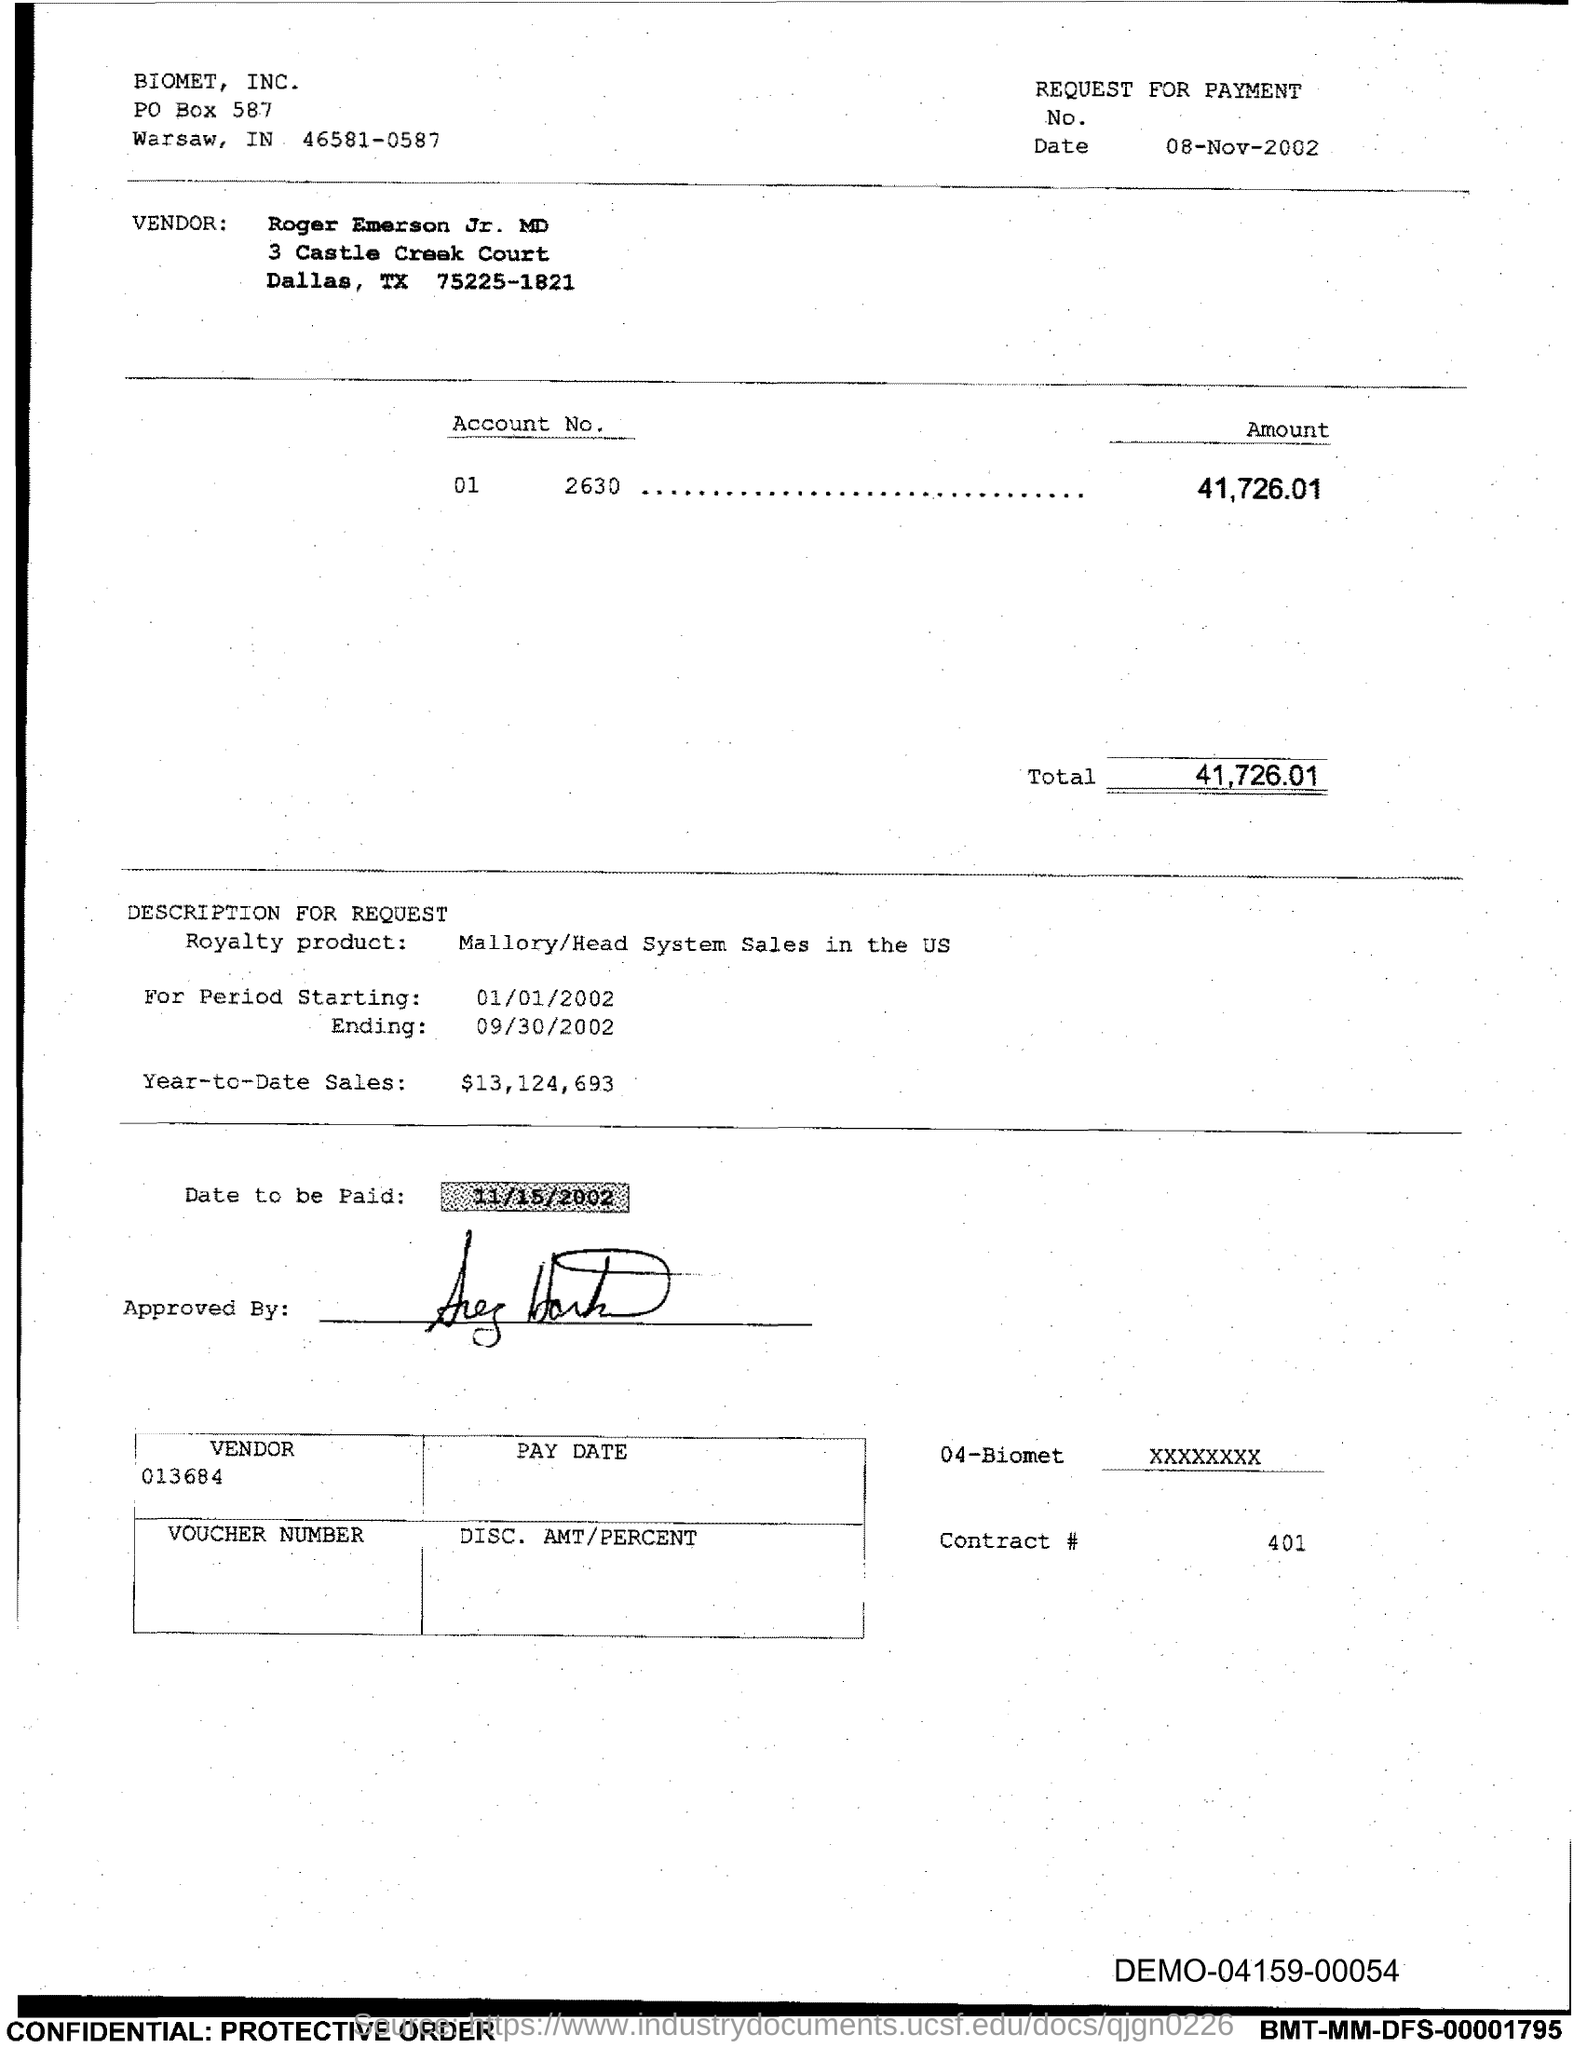Identify some key points in this picture. What is the contract number? It is 401... On what date is the payment due? The payment is due on 11/15/2002. The total is 41,726.01. The PO Box number of Biomet, Inc. is 587. I declare that Biomet, inc. is located in the city of Warsaw. 